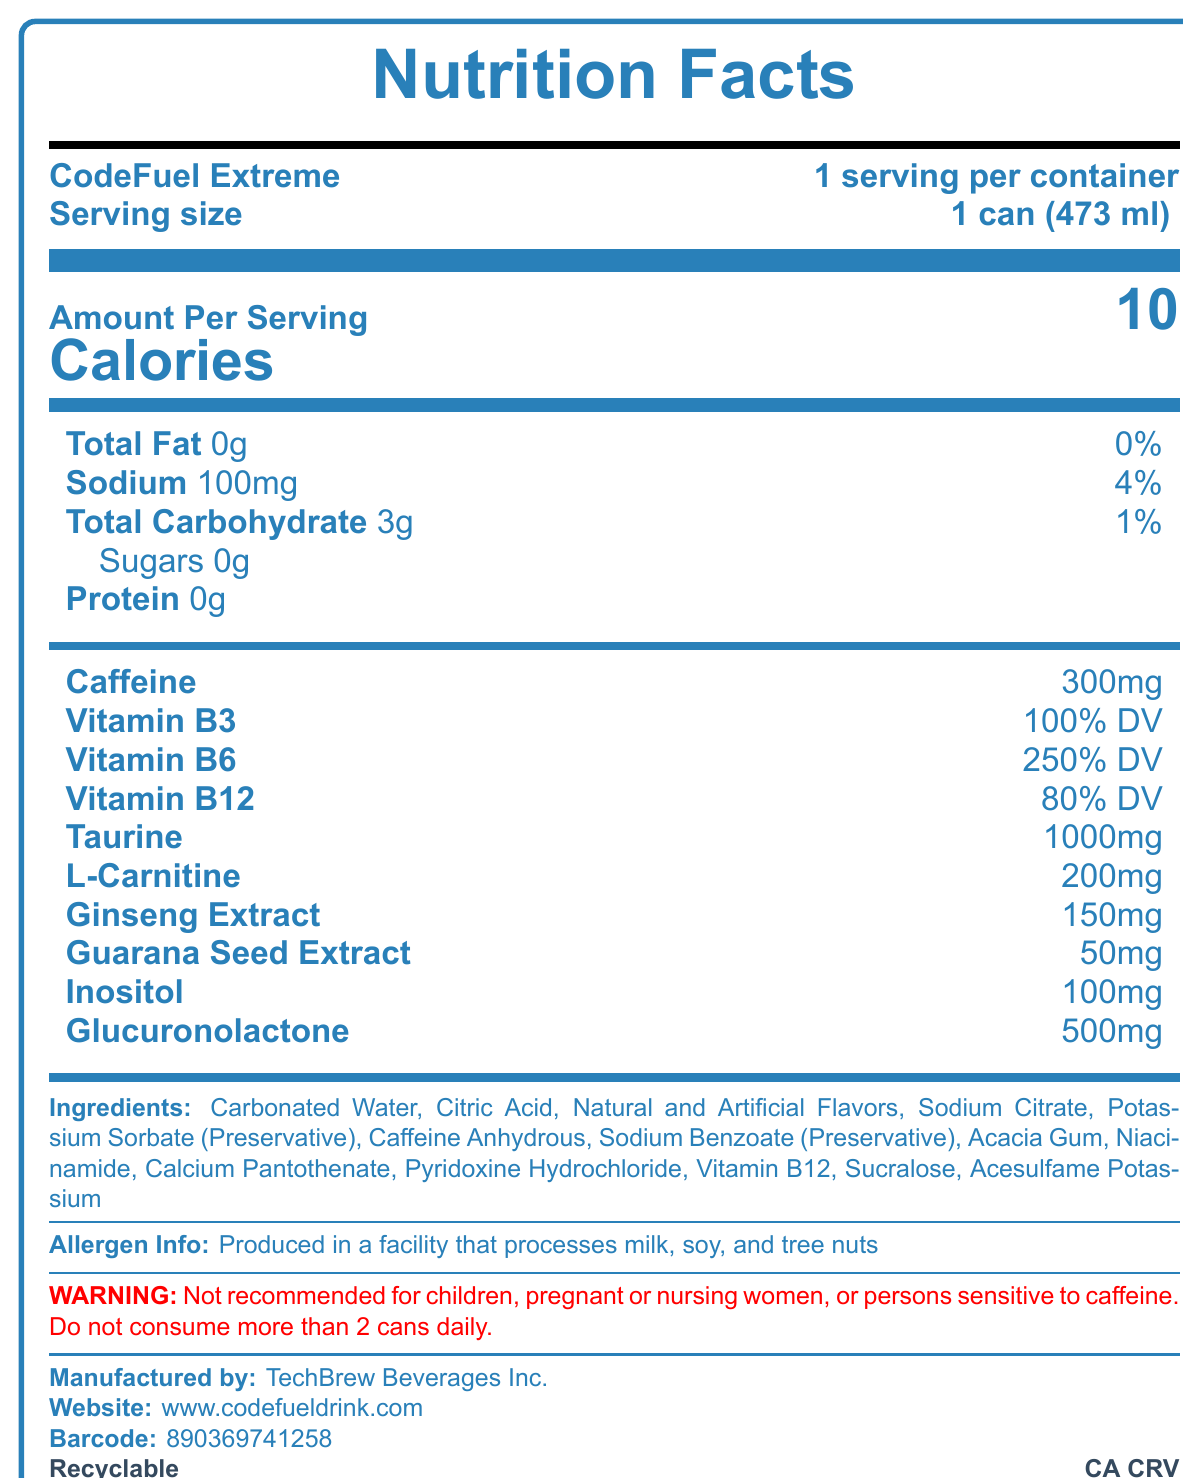What is the serving size for CodeFuel Extreme? The document states that the serving size is 1 can (473 ml).
Answer: 1 can (473 ml) How many calories are in one serving of CodeFuel Extreme? The document mentions that there are 10 calories per serving.
Answer: 10 calories What is the total fat content in one serving? The document lists the total fat content as 0g per serving.
Answer: 0g What is the sodium content in one can of CodeFuel Extreme? The document indicates that the sodium content is 100mg per serving.
Answer: 100mg How much caffeine is in one can of CodeFuel Extreme? The document states that there is 300mg of caffeine per serving.
Answer: 300mg Which ingredient is not listed in the document? A. Acacia Gum B. High Fructose Corn Syrup C. Sodium Benzoate D. Sucralose High Fructose Corn Syrup is not mentioned in the ingredients list.
Answer: B What is the percentage of the daily value of Vitamin B6 in one serving of CodeFuel Extreme? A. 100% B. 150% C. 200% D. 250% The document shows that one serving contains 250% of the daily value for Vitamin B6.
Answer: D Is CodeFuel Extreme safe for children to consume? Yes/No The document contains a warning that it is not recommended for children.
Answer: No Summarize the main details of the Nutrition Facts Label for CodeFuel Extreme. The summary covers the main aspects including nutritional content, ingredient information, allergen warning, and consumption recommendations.
Answer: CodeFuel Extreme is an energy drink with a serving size of 1 can (473 ml). It contains 10 calories, no fat, 100 mg of sodium, 3g of total carbohydrates, no sugars or protein, and 300mg of caffeine. It also includes significant amounts of vitamins B3, B6, and B12, as well as other ingredients like Taurine and L-Carnitine. It contains artificial sweeteners and is produced in a facility that processes milk, soy, and tree nuts. The drink is not recommended for children, pregnant or nursing women, or people sensitive to caffeine, with a consumption limit of 2 cans daily. Explain the warning provided on the Nutrition Facts Label. The document highlights health warnings specific to certain populations and sets a limit on daily consumption to prevent adverse effects from high caffeine intake.
Answer: The product is not recommended for children, pregnant or nursing women, or persons sensitive to caffeine. Additionally, it advises not to consume more than 2 cans daily. How much taurine is in one serving of CodeFuel Extreme? The document lists 1000mg of Taurine in one serving.
Answer: 1000mg Can CodeFuel Extreme be recycled? The document mentions that the container is recyclable.
Answer: Yes Which preservative is found in CodeFuel Extreme? The document lists both Sodium Benzoate and Potassium Sorbate as preservatives.
Answer: Sodium Benzoate, Potassium Sorbate How many total carbohydrates are in one serving of CodeFuel Extreme? The document indicates that there are 3g of total carbohydrates per serving.
Answer: 3g Does the label provide information on whether CodeFuel Extreme contains sugar? The document clearly indicates that the drink contains 0g of sugars.
Answer: Yes What percentage of the daily value of Vitamin B12 does one serving provide? The document lists Vitamin B12 as providing 80% of the daily value per serving.
Answer: 80% DV What is the barcode number for CodeFuel Extreme? The document provides the barcode number as 890369741258.
Answer: 890369741258 Where is CodeFuel Extreme produced? The document states that the manufacturer is TechBrew Beverages Inc.
Answer: TechBrew Beverages Inc. What is the website for more information about CodeFuel Extreme? The document provides the website www.codefueldrink.com for more information.
Answer: www.codefueldrink.com How much guarana seed extract is contained in one serving of CodeFuel Extreme? The document indicates that one serving contains 50mg of guarana seed extract.
Answer: 50mg What is the container deposit value for California? The document mentions CA CRV, indicating the container deposit for California.
Answer: CA CRV Can you determine the exact flavor of CodeFuel Extreme from the document? The document mentions "Natural and Artificial Flavors" but does not specify the exact flavor.
Answer: Cannot be determined 